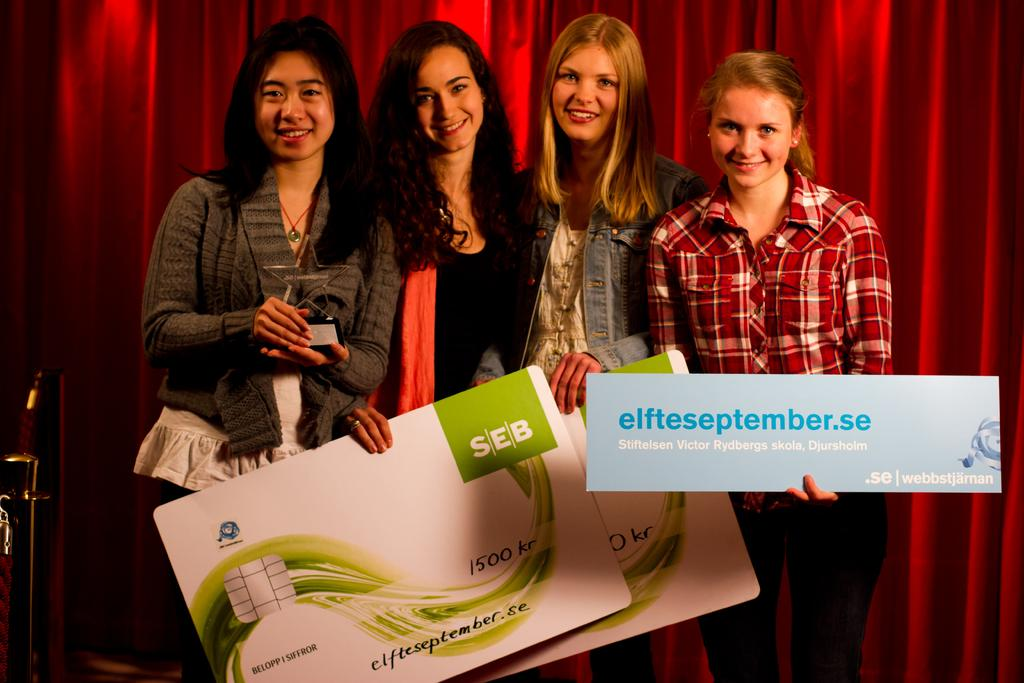How many women are in the image? There are four women in the image. What are the women doing in the image? The women are standing and holding objects in their hands. What is the facial expression of the women in the image? The women are smiling in the image. What can be seen in the background of the image? There are curtains in the background of the image. What scientific experiment are the women conducting in the image? There is no indication of a scientific experiment in the image; the women are simply standing and holding objects. What type of string can be seen in the image? There is no string present in the image. 